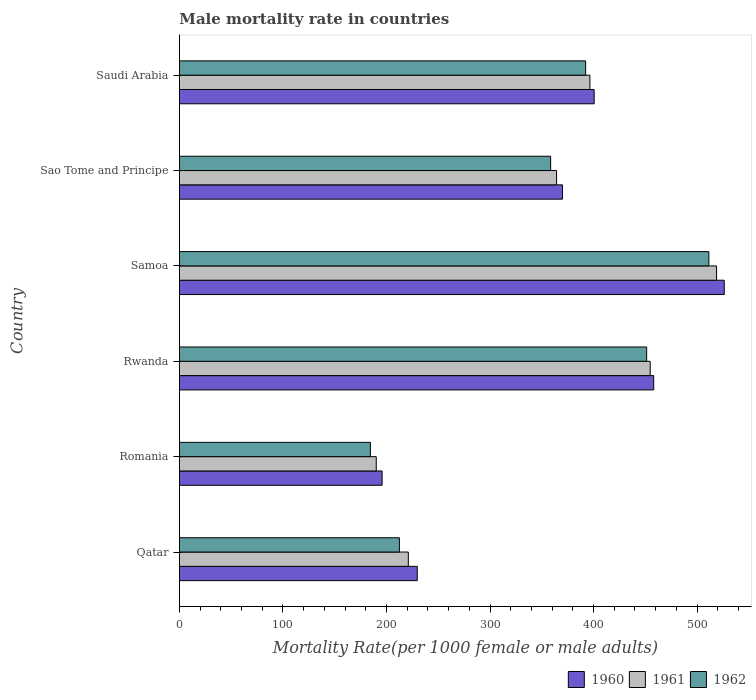How many groups of bars are there?
Offer a very short reply. 6. Are the number of bars on each tick of the Y-axis equal?
Provide a succinct answer. Yes. How many bars are there on the 2nd tick from the bottom?
Offer a terse response. 3. What is the label of the 4th group of bars from the top?
Provide a short and direct response. Rwanda. In how many cases, is the number of bars for a given country not equal to the number of legend labels?
Offer a very short reply. 0. What is the male mortality rate in 1961 in Sao Tome and Principe?
Offer a terse response. 364.26. Across all countries, what is the maximum male mortality rate in 1960?
Your response must be concise. 526.23. Across all countries, what is the minimum male mortality rate in 1961?
Give a very brief answer. 190.12. In which country was the male mortality rate in 1962 maximum?
Offer a terse response. Samoa. In which country was the male mortality rate in 1960 minimum?
Make the answer very short. Romania. What is the total male mortality rate in 1961 in the graph?
Your answer should be very brief. 2145.41. What is the difference between the male mortality rate in 1962 in Qatar and that in Rwanda?
Your response must be concise. -238.83. What is the difference between the male mortality rate in 1962 in Romania and the male mortality rate in 1960 in Rwanda?
Your answer should be very brief. -273.63. What is the average male mortality rate in 1962 per country?
Offer a very short reply. 351.74. What is the difference between the male mortality rate in 1961 and male mortality rate in 1962 in Samoa?
Ensure brevity in your answer.  7.44. What is the ratio of the male mortality rate in 1962 in Romania to that in Samoa?
Give a very brief answer. 0.36. Is the difference between the male mortality rate in 1961 in Romania and Samoa greater than the difference between the male mortality rate in 1962 in Romania and Samoa?
Make the answer very short. No. What is the difference between the highest and the second highest male mortality rate in 1961?
Keep it short and to the point. 64.1. What is the difference between the highest and the lowest male mortality rate in 1962?
Provide a succinct answer. 326.88. In how many countries, is the male mortality rate in 1962 greater than the average male mortality rate in 1962 taken over all countries?
Provide a succinct answer. 4. Is it the case that in every country, the sum of the male mortality rate in 1960 and male mortality rate in 1961 is greater than the male mortality rate in 1962?
Offer a very short reply. Yes. How many bars are there?
Ensure brevity in your answer.  18. Are all the bars in the graph horizontal?
Provide a short and direct response. Yes. Are the values on the major ticks of X-axis written in scientific E-notation?
Make the answer very short. No. Does the graph contain any zero values?
Provide a short and direct response. No. How are the legend labels stacked?
Offer a very short reply. Horizontal. What is the title of the graph?
Your response must be concise. Male mortality rate in countries. Does "1965" appear as one of the legend labels in the graph?
Keep it short and to the point. No. What is the label or title of the X-axis?
Keep it short and to the point. Mortality Rate(per 1000 female or male adults). What is the label or title of the Y-axis?
Give a very brief answer. Country. What is the Mortality Rate(per 1000 female or male adults) of 1960 in Qatar?
Keep it short and to the point. 229.71. What is the Mortality Rate(per 1000 female or male adults) in 1961 in Qatar?
Offer a terse response. 221.08. What is the Mortality Rate(per 1000 female or male adults) in 1962 in Qatar?
Provide a succinct answer. 212.46. What is the Mortality Rate(per 1000 female or male adults) in 1960 in Romania?
Make the answer very short. 195.77. What is the Mortality Rate(per 1000 female or male adults) in 1961 in Romania?
Make the answer very short. 190.12. What is the Mortality Rate(per 1000 female or male adults) of 1962 in Romania?
Make the answer very short. 184.47. What is the Mortality Rate(per 1000 female or male adults) in 1960 in Rwanda?
Provide a short and direct response. 458.1. What is the Mortality Rate(per 1000 female or male adults) of 1961 in Rwanda?
Offer a very short reply. 454.69. What is the Mortality Rate(per 1000 female or male adults) in 1962 in Rwanda?
Your answer should be compact. 451.29. What is the Mortality Rate(per 1000 female or male adults) of 1960 in Samoa?
Your response must be concise. 526.23. What is the Mortality Rate(per 1000 female or male adults) of 1961 in Samoa?
Provide a succinct answer. 518.79. What is the Mortality Rate(per 1000 female or male adults) of 1962 in Samoa?
Provide a short and direct response. 511.35. What is the Mortality Rate(per 1000 female or male adults) of 1960 in Sao Tome and Principe?
Give a very brief answer. 369.99. What is the Mortality Rate(per 1000 female or male adults) of 1961 in Sao Tome and Principe?
Provide a short and direct response. 364.26. What is the Mortality Rate(per 1000 female or male adults) in 1962 in Sao Tome and Principe?
Your answer should be compact. 358.54. What is the Mortality Rate(per 1000 female or male adults) in 1960 in Saudi Arabia?
Provide a short and direct response. 400.58. What is the Mortality Rate(per 1000 female or male adults) of 1961 in Saudi Arabia?
Keep it short and to the point. 396.47. What is the Mortality Rate(per 1000 female or male adults) of 1962 in Saudi Arabia?
Ensure brevity in your answer.  392.35. Across all countries, what is the maximum Mortality Rate(per 1000 female or male adults) of 1960?
Keep it short and to the point. 526.23. Across all countries, what is the maximum Mortality Rate(per 1000 female or male adults) of 1961?
Your answer should be very brief. 518.79. Across all countries, what is the maximum Mortality Rate(per 1000 female or male adults) in 1962?
Provide a short and direct response. 511.35. Across all countries, what is the minimum Mortality Rate(per 1000 female or male adults) of 1960?
Give a very brief answer. 195.77. Across all countries, what is the minimum Mortality Rate(per 1000 female or male adults) in 1961?
Ensure brevity in your answer.  190.12. Across all countries, what is the minimum Mortality Rate(per 1000 female or male adults) in 1962?
Your answer should be compact. 184.47. What is the total Mortality Rate(per 1000 female or male adults) in 1960 in the graph?
Offer a very short reply. 2180.36. What is the total Mortality Rate(per 1000 female or male adults) of 1961 in the graph?
Ensure brevity in your answer.  2145.41. What is the total Mortality Rate(per 1000 female or male adults) in 1962 in the graph?
Provide a succinct answer. 2110.47. What is the difference between the Mortality Rate(per 1000 female or male adults) of 1960 in Qatar and that in Romania?
Ensure brevity in your answer.  33.94. What is the difference between the Mortality Rate(per 1000 female or male adults) in 1961 in Qatar and that in Romania?
Provide a succinct answer. 30.97. What is the difference between the Mortality Rate(per 1000 female or male adults) of 1962 in Qatar and that in Romania?
Provide a succinct answer. 27.99. What is the difference between the Mortality Rate(per 1000 female or male adults) in 1960 in Qatar and that in Rwanda?
Ensure brevity in your answer.  -228.39. What is the difference between the Mortality Rate(per 1000 female or male adults) of 1961 in Qatar and that in Rwanda?
Give a very brief answer. -233.61. What is the difference between the Mortality Rate(per 1000 female or male adults) in 1962 in Qatar and that in Rwanda?
Make the answer very short. -238.83. What is the difference between the Mortality Rate(per 1000 female or male adults) of 1960 in Qatar and that in Samoa?
Your response must be concise. -296.52. What is the difference between the Mortality Rate(per 1000 female or male adults) of 1961 in Qatar and that in Samoa?
Provide a short and direct response. -297.71. What is the difference between the Mortality Rate(per 1000 female or male adults) of 1962 in Qatar and that in Samoa?
Make the answer very short. -298.89. What is the difference between the Mortality Rate(per 1000 female or male adults) in 1960 in Qatar and that in Sao Tome and Principe?
Provide a succinct answer. -140.28. What is the difference between the Mortality Rate(per 1000 female or male adults) of 1961 in Qatar and that in Sao Tome and Principe?
Provide a succinct answer. -143.18. What is the difference between the Mortality Rate(per 1000 female or male adults) in 1962 in Qatar and that in Sao Tome and Principe?
Your response must be concise. -146.08. What is the difference between the Mortality Rate(per 1000 female or male adults) of 1960 in Qatar and that in Saudi Arabia?
Your response must be concise. -170.88. What is the difference between the Mortality Rate(per 1000 female or male adults) in 1961 in Qatar and that in Saudi Arabia?
Provide a succinct answer. -175.38. What is the difference between the Mortality Rate(per 1000 female or male adults) in 1962 in Qatar and that in Saudi Arabia?
Keep it short and to the point. -179.89. What is the difference between the Mortality Rate(per 1000 female or male adults) in 1960 in Romania and that in Rwanda?
Offer a terse response. -262.33. What is the difference between the Mortality Rate(per 1000 female or male adults) of 1961 in Romania and that in Rwanda?
Offer a very short reply. -264.57. What is the difference between the Mortality Rate(per 1000 female or male adults) of 1962 in Romania and that in Rwanda?
Ensure brevity in your answer.  -266.82. What is the difference between the Mortality Rate(per 1000 female or male adults) of 1960 in Romania and that in Samoa?
Your response must be concise. -330.46. What is the difference between the Mortality Rate(per 1000 female or male adults) of 1961 in Romania and that in Samoa?
Your response must be concise. -328.67. What is the difference between the Mortality Rate(per 1000 female or male adults) of 1962 in Romania and that in Samoa?
Offer a very short reply. -326.88. What is the difference between the Mortality Rate(per 1000 female or male adults) of 1960 in Romania and that in Sao Tome and Principe?
Provide a short and direct response. -174.22. What is the difference between the Mortality Rate(per 1000 female or male adults) in 1961 in Romania and that in Sao Tome and Principe?
Make the answer very short. -174.15. What is the difference between the Mortality Rate(per 1000 female or male adults) of 1962 in Romania and that in Sao Tome and Principe?
Your response must be concise. -174.07. What is the difference between the Mortality Rate(per 1000 female or male adults) in 1960 in Romania and that in Saudi Arabia?
Provide a short and direct response. -204.81. What is the difference between the Mortality Rate(per 1000 female or male adults) in 1961 in Romania and that in Saudi Arabia?
Your answer should be very brief. -206.35. What is the difference between the Mortality Rate(per 1000 female or male adults) in 1962 in Romania and that in Saudi Arabia?
Make the answer very short. -207.88. What is the difference between the Mortality Rate(per 1000 female or male adults) in 1960 in Rwanda and that in Samoa?
Give a very brief answer. -68.13. What is the difference between the Mortality Rate(per 1000 female or male adults) in 1961 in Rwanda and that in Samoa?
Offer a very short reply. -64.1. What is the difference between the Mortality Rate(per 1000 female or male adults) in 1962 in Rwanda and that in Samoa?
Provide a succinct answer. -60.07. What is the difference between the Mortality Rate(per 1000 female or male adults) of 1960 in Rwanda and that in Sao Tome and Principe?
Offer a very short reply. 88.11. What is the difference between the Mortality Rate(per 1000 female or male adults) in 1961 in Rwanda and that in Sao Tome and Principe?
Provide a short and direct response. 90.43. What is the difference between the Mortality Rate(per 1000 female or male adults) of 1962 in Rwanda and that in Sao Tome and Principe?
Your answer should be very brief. 92.75. What is the difference between the Mortality Rate(per 1000 female or male adults) of 1960 in Rwanda and that in Saudi Arabia?
Your answer should be very brief. 57.52. What is the difference between the Mortality Rate(per 1000 female or male adults) of 1961 in Rwanda and that in Saudi Arabia?
Give a very brief answer. 58.23. What is the difference between the Mortality Rate(per 1000 female or male adults) of 1962 in Rwanda and that in Saudi Arabia?
Provide a short and direct response. 58.94. What is the difference between the Mortality Rate(per 1000 female or male adults) of 1960 in Samoa and that in Sao Tome and Principe?
Provide a succinct answer. 156.24. What is the difference between the Mortality Rate(per 1000 female or male adults) of 1961 in Samoa and that in Sao Tome and Principe?
Your response must be concise. 154.52. What is the difference between the Mortality Rate(per 1000 female or male adults) in 1962 in Samoa and that in Sao Tome and Principe?
Make the answer very short. 152.81. What is the difference between the Mortality Rate(per 1000 female or male adults) of 1960 in Samoa and that in Saudi Arabia?
Provide a short and direct response. 125.64. What is the difference between the Mortality Rate(per 1000 female or male adults) of 1961 in Samoa and that in Saudi Arabia?
Ensure brevity in your answer.  122.32. What is the difference between the Mortality Rate(per 1000 female or male adults) of 1962 in Samoa and that in Saudi Arabia?
Keep it short and to the point. 119. What is the difference between the Mortality Rate(per 1000 female or male adults) in 1960 in Sao Tome and Principe and that in Saudi Arabia?
Offer a terse response. -30.59. What is the difference between the Mortality Rate(per 1000 female or male adults) of 1961 in Sao Tome and Principe and that in Saudi Arabia?
Ensure brevity in your answer.  -32.2. What is the difference between the Mortality Rate(per 1000 female or male adults) of 1962 in Sao Tome and Principe and that in Saudi Arabia?
Offer a very short reply. -33.81. What is the difference between the Mortality Rate(per 1000 female or male adults) of 1960 in Qatar and the Mortality Rate(per 1000 female or male adults) of 1961 in Romania?
Your answer should be very brief. 39.59. What is the difference between the Mortality Rate(per 1000 female or male adults) of 1960 in Qatar and the Mortality Rate(per 1000 female or male adults) of 1962 in Romania?
Your answer should be very brief. 45.24. What is the difference between the Mortality Rate(per 1000 female or male adults) of 1961 in Qatar and the Mortality Rate(per 1000 female or male adults) of 1962 in Romania?
Your response must be concise. 36.61. What is the difference between the Mortality Rate(per 1000 female or male adults) of 1960 in Qatar and the Mortality Rate(per 1000 female or male adults) of 1961 in Rwanda?
Keep it short and to the point. -224.99. What is the difference between the Mortality Rate(per 1000 female or male adults) of 1960 in Qatar and the Mortality Rate(per 1000 female or male adults) of 1962 in Rwanda?
Your response must be concise. -221.58. What is the difference between the Mortality Rate(per 1000 female or male adults) in 1961 in Qatar and the Mortality Rate(per 1000 female or male adults) in 1962 in Rwanda?
Your response must be concise. -230.21. What is the difference between the Mortality Rate(per 1000 female or male adults) in 1960 in Qatar and the Mortality Rate(per 1000 female or male adults) in 1961 in Samoa?
Give a very brief answer. -289.08. What is the difference between the Mortality Rate(per 1000 female or male adults) in 1960 in Qatar and the Mortality Rate(per 1000 female or male adults) in 1962 in Samoa?
Your answer should be very brief. -281.65. What is the difference between the Mortality Rate(per 1000 female or male adults) of 1961 in Qatar and the Mortality Rate(per 1000 female or male adults) of 1962 in Samoa?
Keep it short and to the point. -290.27. What is the difference between the Mortality Rate(per 1000 female or male adults) in 1960 in Qatar and the Mortality Rate(per 1000 female or male adults) in 1961 in Sao Tome and Principe?
Your response must be concise. -134.56. What is the difference between the Mortality Rate(per 1000 female or male adults) of 1960 in Qatar and the Mortality Rate(per 1000 female or male adults) of 1962 in Sao Tome and Principe?
Offer a very short reply. -128.84. What is the difference between the Mortality Rate(per 1000 female or male adults) in 1961 in Qatar and the Mortality Rate(per 1000 female or male adults) in 1962 in Sao Tome and Principe?
Offer a very short reply. -137.46. What is the difference between the Mortality Rate(per 1000 female or male adults) of 1960 in Qatar and the Mortality Rate(per 1000 female or male adults) of 1961 in Saudi Arabia?
Make the answer very short. -166.76. What is the difference between the Mortality Rate(per 1000 female or male adults) in 1960 in Qatar and the Mortality Rate(per 1000 female or male adults) in 1962 in Saudi Arabia?
Your answer should be compact. -162.65. What is the difference between the Mortality Rate(per 1000 female or male adults) in 1961 in Qatar and the Mortality Rate(per 1000 female or male adults) in 1962 in Saudi Arabia?
Ensure brevity in your answer.  -171.27. What is the difference between the Mortality Rate(per 1000 female or male adults) in 1960 in Romania and the Mortality Rate(per 1000 female or male adults) in 1961 in Rwanda?
Give a very brief answer. -258.93. What is the difference between the Mortality Rate(per 1000 female or male adults) in 1960 in Romania and the Mortality Rate(per 1000 female or male adults) in 1962 in Rwanda?
Provide a short and direct response. -255.52. What is the difference between the Mortality Rate(per 1000 female or male adults) of 1961 in Romania and the Mortality Rate(per 1000 female or male adults) of 1962 in Rwanda?
Ensure brevity in your answer.  -261.17. What is the difference between the Mortality Rate(per 1000 female or male adults) in 1960 in Romania and the Mortality Rate(per 1000 female or male adults) in 1961 in Samoa?
Provide a succinct answer. -323.02. What is the difference between the Mortality Rate(per 1000 female or male adults) in 1960 in Romania and the Mortality Rate(per 1000 female or male adults) in 1962 in Samoa?
Give a very brief answer. -315.59. What is the difference between the Mortality Rate(per 1000 female or male adults) in 1961 in Romania and the Mortality Rate(per 1000 female or male adults) in 1962 in Samoa?
Make the answer very short. -321.24. What is the difference between the Mortality Rate(per 1000 female or male adults) of 1960 in Romania and the Mortality Rate(per 1000 female or male adults) of 1961 in Sao Tome and Principe?
Your response must be concise. -168.5. What is the difference between the Mortality Rate(per 1000 female or male adults) of 1960 in Romania and the Mortality Rate(per 1000 female or male adults) of 1962 in Sao Tome and Principe?
Make the answer very short. -162.78. What is the difference between the Mortality Rate(per 1000 female or male adults) in 1961 in Romania and the Mortality Rate(per 1000 female or male adults) in 1962 in Sao Tome and Principe?
Ensure brevity in your answer.  -168.43. What is the difference between the Mortality Rate(per 1000 female or male adults) in 1960 in Romania and the Mortality Rate(per 1000 female or male adults) in 1961 in Saudi Arabia?
Make the answer very short. -200.7. What is the difference between the Mortality Rate(per 1000 female or male adults) of 1960 in Romania and the Mortality Rate(per 1000 female or male adults) of 1962 in Saudi Arabia?
Provide a succinct answer. -196.59. What is the difference between the Mortality Rate(per 1000 female or male adults) of 1961 in Romania and the Mortality Rate(per 1000 female or male adults) of 1962 in Saudi Arabia?
Make the answer very short. -202.23. What is the difference between the Mortality Rate(per 1000 female or male adults) in 1960 in Rwanda and the Mortality Rate(per 1000 female or male adults) in 1961 in Samoa?
Your answer should be very brief. -60.69. What is the difference between the Mortality Rate(per 1000 female or male adults) of 1960 in Rwanda and the Mortality Rate(per 1000 female or male adults) of 1962 in Samoa?
Provide a short and direct response. -53.26. What is the difference between the Mortality Rate(per 1000 female or male adults) of 1961 in Rwanda and the Mortality Rate(per 1000 female or male adults) of 1962 in Samoa?
Give a very brief answer. -56.66. What is the difference between the Mortality Rate(per 1000 female or male adults) in 1960 in Rwanda and the Mortality Rate(per 1000 female or male adults) in 1961 in Sao Tome and Principe?
Provide a short and direct response. 93.83. What is the difference between the Mortality Rate(per 1000 female or male adults) of 1960 in Rwanda and the Mortality Rate(per 1000 female or male adults) of 1962 in Sao Tome and Principe?
Keep it short and to the point. 99.55. What is the difference between the Mortality Rate(per 1000 female or male adults) in 1961 in Rwanda and the Mortality Rate(per 1000 female or male adults) in 1962 in Sao Tome and Principe?
Ensure brevity in your answer.  96.15. What is the difference between the Mortality Rate(per 1000 female or male adults) of 1960 in Rwanda and the Mortality Rate(per 1000 female or male adults) of 1961 in Saudi Arabia?
Your answer should be compact. 61.63. What is the difference between the Mortality Rate(per 1000 female or male adults) of 1960 in Rwanda and the Mortality Rate(per 1000 female or male adults) of 1962 in Saudi Arabia?
Your answer should be very brief. 65.75. What is the difference between the Mortality Rate(per 1000 female or male adults) in 1961 in Rwanda and the Mortality Rate(per 1000 female or male adults) in 1962 in Saudi Arabia?
Give a very brief answer. 62.34. What is the difference between the Mortality Rate(per 1000 female or male adults) in 1960 in Samoa and the Mortality Rate(per 1000 female or male adults) in 1961 in Sao Tome and Principe?
Offer a terse response. 161.96. What is the difference between the Mortality Rate(per 1000 female or male adults) in 1960 in Samoa and the Mortality Rate(per 1000 female or male adults) in 1962 in Sao Tome and Principe?
Offer a terse response. 167.68. What is the difference between the Mortality Rate(per 1000 female or male adults) of 1961 in Samoa and the Mortality Rate(per 1000 female or male adults) of 1962 in Sao Tome and Principe?
Ensure brevity in your answer.  160.25. What is the difference between the Mortality Rate(per 1000 female or male adults) of 1960 in Samoa and the Mortality Rate(per 1000 female or male adults) of 1961 in Saudi Arabia?
Provide a short and direct response. 129.76. What is the difference between the Mortality Rate(per 1000 female or male adults) of 1960 in Samoa and the Mortality Rate(per 1000 female or male adults) of 1962 in Saudi Arabia?
Give a very brief answer. 133.87. What is the difference between the Mortality Rate(per 1000 female or male adults) of 1961 in Samoa and the Mortality Rate(per 1000 female or male adults) of 1962 in Saudi Arabia?
Give a very brief answer. 126.44. What is the difference between the Mortality Rate(per 1000 female or male adults) of 1960 in Sao Tome and Principe and the Mortality Rate(per 1000 female or male adults) of 1961 in Saudi Arabia?
Your response must be concise. -26.48. What is the difference between the Mortality Rate(per 1000 female or male adults) of 1960 in Sao Tome and Principe and the Mortality Rate(per 1000 female or male adults) of 1962 in Saudi Arabia?
Give a very brief answer. -22.36. What is the difference between the Mortality Rate(per 1000 female or male adults) of 1961 in Sao Tome and Principe and the Mortality Rate(per 1000 female or male adults) of 1962 in Saudi Arabia?
Ensure brevity in your answer.  -28.09. What is the average Mortality Rate(per 1000 female or male adults) in 1960 per country?
Offer a terse response. 363.39. What is the average Mortality Rate(per 1000 female or male adults) of 1961 per country?
Make the answer very short. 357.57. What is the average Mortality Rate(per 1000 female or male adults) in 1962 per country?
Offer a terse response. 351.74. What is the difference between the Mortality Rate(per 1000 female or male adults) of 1960 and Mortality Rate(per 1000 female or male adults) of 1961 in Qatar?
Ensure brevity in your answer.  8.62. What is the difference between the Mortality Rate(per 1000 female or male adults) of 1960 and Mortality Rate(per 1000 female or male adults) of 1962 in Qatar?
Make the answer very short. 17.25. What is the difference between the Mortality Rate(per 1000 female or male adults) in 1961 and Mortality Rate(per 1000 female or male adults) in 1962 in Qatar?
Ensure brevity in your answer.  8.62. What is the difference between the Mortality Rate(per 1000 female or male adults) of 1960 and Mortality Rate(per 1000 female or male adults) of 1961 in Romania?
Give a very brief answer. 5.65. What is the difference between the Mortality Rate(per 1000 female or male adults) in 1960 and Mortality Rate(per 1000 female or male adults) in 1962 in Romania?
Provide a short and direct response. 11.3. What is the difference between the Mortality Rate(per 1000 female or male adults) of 1961 and Mortality Rate(per 1000 female or male adults) of 1962 in Romania?
Provide a succinct answer. 5.65. What is the difference between the Mortality Rate(per 1000 female or male adults) in 1960 and Mortality Rate(per 1000 female or male adults) in 1961 in Rwanda?
Offer a very short reply. 3.4. What is the difference between the Mortality Rate(per 1000 female or male adults) in 1960 and Mortality Rate(per 1000 female or male adults) in 1962 in Rwanda?
Your answer should be compact. 6.81. What is the difference between the Mortality Rate(per 1000 female or male adults) of 1961 and Mortality Rate(per 1000 female or male adults) of 1962 in Rwanda?
Ensure brevity in your answer.  3.4. What is the difference between the Mortality Rate(per 1000 female or male adults) in 1960 and Mortality Rate(per 1000 female or male adults) in 1961 in Samoa?
Your answer should be compact. 7.44. What is the difference between the Mortality Rate(per 1000 female or male adults) of 1960 and Mortality Rate(per 1000 female or male adults) of 1962 in Samoa?
Your answer should be compact. 14.87. What is the difference between the Mortality Rate(per 1000 female or male adults) in 1961 and Mortality Rate(per 1000 female or male adults) in 1962 in Samoa?
Ensure brevity in your answer.  7.43. What is the difference between the Mortality Rate(per 1000 female or male adults) in 1960 and Mortality Rate(per 1000 female or male adults) in 1961 in Sao Tome and Principe?
Keep it short and to the point. 5.72. What is the difference between the Mortality Rate(per 1000 female or male adults) of 1960 and Mortality Rate(per 1000 female or male adults) of 1962 in Sao Tome and Principe?
Make the answer very short. 11.44. What is the difference between the Mortality Rate(per 1000 female or male adults) in 1961 and Mortality Rate(per 1000 female or male adults) in 1962 in Sao Tome and Principe?
Offer a terse response. 5.72. What is the difference between the Mortality Rate(per 1000 female or male adults) in 1960 and Mortality Rate(per 1000 female or male adults) in 1961 in Saudi Arabia?
Your response must be concise. 4.11. What is the difference between the Mortality Rate(per 1000 female or male adults) of 1960 and Mortality Rate(per 1000 female or male adults) of 1962 in Saudi Arabia?
Give a very brief answer. 8.23. What is the difference between the Mortality Rate(per 1000 female or male adults) in 1961 and Mortality Rate(per 1000 female or male adults) in 1962 in Saudi Arabia?
Offer a terse response. 4.12. What is the ratio of the Mortality Rate(per 1000 female or male adults) of 1960 in Qatar to that in Romania?
Keep it short and to the point. 1.17. What is the ratio of the Mortality Rate(per 1000 female or male adults) of 1961 in Qatar to that in Romania?
Your response must be concise. 1.16. What is the ratio of the Mortality Rate(per 1000 female or male adults) in 1962 in Qatar to that in Romania?
Your answer should be very brief. 1.15. What is the ratio of the Mortality Rate(per 1000 female or male adults) in 1960 in Qatar to that in Rwanda?
Offer a very short reply. 0.5. What is the ratio of the Mortality Rate(per 1000 female or male adults) in 1961 in Qatar to that in Rwanda?
Your response must be concise. 0.49. What is the ratio of the Mortality Rate(per 1000 female or male adults) of 1962 in Qatar to that in Rwanda?
Your answer should be compact. 0.47. What is the ratio of the Mortality Rate(per 1000 female or male adults) of 1960 in Qatar to that in Samoa?
Your answer should be compact. 0.44. What is the ratio of the Mortality Rate(per 1000 female or male adults) in 1961 in Qatar to that in Samoa?
Make the answer very short. 0.43. What is the ratio of the Mortality Rate(per 1000 female or male adults) in 1962 in Qatar to that in Samoa?
Your answer should be compact. 0.42. What is the ratio of the Mortality Rate(per 1000 female or male adults) in 1960 in Qatar to that in Sao Tome and Principe?
Make the answer very short. 0.62. What is the ratio of the Mortality Rate(per 1000 female or male adults) of 1961 in Qatar to that in Sao Tome and Principe?
Give a very brief answer. 0.61. What is the ratio of the Mortality Rate(per 1000 female or male adults) of 1962 in Qatar to that in Sao Tome and Principe?
Provide a succinct answer. 0.59. What is the ratio of the Mortality Rate(per 1000 female or male adults) in 1960 in Qatar to that in Saudi Arabia?
Your answer should be compact. 0.57. What is the ratio of the Mortality Rate(per 1000 female or male adults) in 1961 in Qatar to that in Saudi Arabia?
Provide a succinct answer. 0.56. What is the ratio of the Mortality Rate(per 1000 female or male adults) in 1962 in Qatar to that in Saudi Arabia?
Give a very brief answer. 0.54. What is the ratio of the Mortality Rate(per 1000 female or male adults) of 1960 in Romania to that in Rwanda?
Offer a very short reply. 0.43. What is the ratio of the Mortality Rate(per 1000 female or male adults) of 1961 in Romania to that in Rwanda?
Make the answer very short. 0.42. What is the ratio of the Mortality Rate(per 1000 female or male adults) of 1962 in Romania to that in Rwanda?
Provide a succinct answer. 0.41. What is the ratio of the Mortality Rate(per 1000 female or male adults) of 1960 in Romania to that in Samoa?
Keep it short and to the point. 0.37. What is the ratio of the Mortality Rate(per 1000 female or male adults) of 1961 in Romania to that in Samoa?
Your answer should be compact. 0.37. What is the ratio of the Mortality Rate(per 1000 female or male adults) of 1962 in Romania to that in Samoa?
Offer a very short reply. 0.36. What is the ratio of the Mortality Rate(per 1000 female or male adults) in 1960 in Romania to that in Sao Tome and Principe?
Your answer should be very brief. 0.53. What is the ratio of the Mortality Rate(per 1000 female or male adults) in 1961 in Romania to that in Sao Tome and Principe?
Make the answer very short. 0.52. What is the ratio of the Mortality Rate(per 1000 female or male adults) of 1962 in Romania to that in Sao Tome and Principe?
Your answer should be compact. 0.51. What is the ratio of the Mortality Rate(per 1000 female or male adults) of 1960 in Romania to that in Saudi Arabia?
Keep it short and to the point. 0.49. What is the ratio of the Mortality Rate(per 1000 female or male adults) in 1961 in Romania to that in Saudi Arabia?
Provide a short and direct response. 0.48. What is the ratio of the Mortality Rate(per 1000 female or male adults) in 1962 in Romania to that in Saudi Arabia?
Provide a short and direct response. 0.47. What is the ratio of the Mortality Rate(per 1000 female or male adults) of 1960 in Rwanda to that in Samoa?
Keep it short and to the point. 0.87. What is the ratio of the Mortality Rate(per 1000 female or male adults) of 1961 in Rwanda to that in Samoa?
Make the answer very short. 0.88. What is the ratio of the Mortality Rate(per 1000 female or male adults) in 1962 in Rwanda to that in Samoa?
Offer a very short reply. 0.88. What is the ratio of the Mortality Rate(per 1000 female or male adults) of 1960 in Rwanda to that in Sao Tome and Principe?
Keep it short and to the point. 1.24. What is the ratio of the Mortality Rate(per 1000 female or male adults) of 1961 in Rwanda to that in Sao Tome and Principe?
Make the answer very short. 1.25. What is the ratio of the Mortality Rate(per 1000 female or male adults) of 1962 in Rwanda to that in Sao Tome and Principe?
Your response must be concise. 1.26. What is the ratio of the Mortality Rate(per 1000 female or male adults) in 1960 in Rwanda to that in Saudi Arabia?
Your response must be concise. 1.14. What is the ratio of the Mortality Rate(per 1000 female or male adults) of 1961 in Rwanda to that in Saudi Arabia?
Provide a short and direct response. 1.15. What is the ratio of the Mortality Rate(per 1000 female or male adults) of 1962 in Rwanda to that in Saudi Arabia?
Your answer should be very brief. 1.15. What is the ratio of the Mortality Rate(per 1000 female or male adults) of 1960 in Samoa to that in Sao Tome and Principe?
Provide a short and direct response. 1.42. What is the ratio of the Mortality Rate(per 1000 female or male adults) in 1961 in Samoa to that in Sao Tome and Principe?
Offer a very short reply. 1.42. What is the ratio of the Mortality Rate(per 1000 female or male adults) of 1962 in Samoa to that in Sao Tome and Principe?
Ensure brevity in your answer.  1.43. What is the ratio of the Mortality Rate(per 1000 female or male adults) in 1960 in Samoa to that in Saudi Arabia?
Provide a short and direct response. 1.31. What is the ratio of the Mortality Rate(per 1000 female or male adults) of 1961 in Samoa to that in Saudi Arabia?
Ensure brevity in your answer.  1.31. What is the ratio of the Mortality Rate(per 1000 female or male adults) of 1962 in Samoa to that in Saudi Arabia?
Make the answer very short. 1.3. What is the ratio of the Mortality Rate(per 1000 female or male adults) in 1960 in Sao Tome and Principe to that in Saudi Arabia?
Offer a terse response. 0.92. What is the ratio of the Mortality Rate(per 1000 female or male adults) in 1961 in Sao Tome and Principe to that in Saudi Arabia?
Keep it short and to the point. 0.92. What is the ratio of the Mortality Rate(per 1000 female or male adults) in 1962 in Sao Tome and Principe to that in Saudi Arabia?
Your answer should be compact. 0.91. What is the difference between the highest and the second highest Mortality Rate(per 1000 female or male adults) of 1960?
Give a very brief answer. 68.13. What is the difference between the highest and the second highest Mortality Rate(per 1000 female or male adults) of 1961?
Offer a very short reply. 64.1. What is the difference between the highest and the second highest Mortality Rate(per 1000 female or male adults) of 1962?
Ensure brevity in your answer.  60.07. What is the difference between the highest and the lowest Mortality Rate(per 1000 female or male adults) in 1960?
Your answer should be compact. 330.46. What is the difference between the highest and the lowest Mortality Rate(per 1000 female or male adults) in 1961?
Your response must be concise. 328.67. What is the difference between the highest and the lowest Mortality Rate(per 1000 female or male adults) in 1962?
Ensure brevity in your answer.  326.88. 